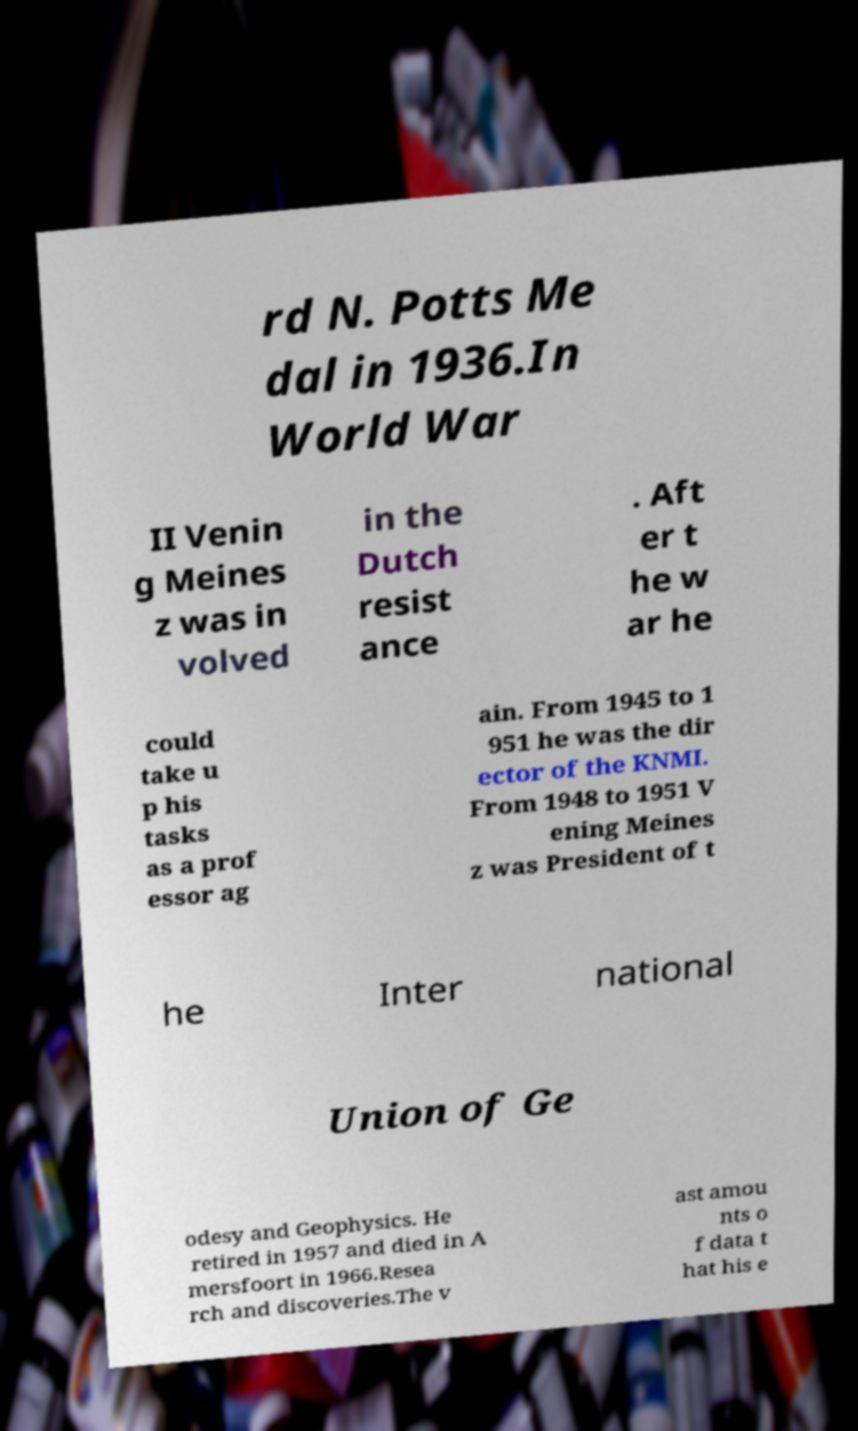There's text embedded in this image that I need extracted. Can you transcribe it verbatim? rd N. Potts Me dal in 1936.In World War II Venin g Meines z was in volved in the Dutch resist ance . Aft er t he w ar he could take u p his tasks as a prof essor ag ain. From 1945 to 1 951 he was the dir ector of the KNMI. From 1948 to 1951 V ening Meines z was President of t he Inter national Union of Ge odesy and Geophysics. He retired in 1957 and died in A mersfoort in 1966.Resea rch and discoveries.The v ast amou nts o f data t hat his e 